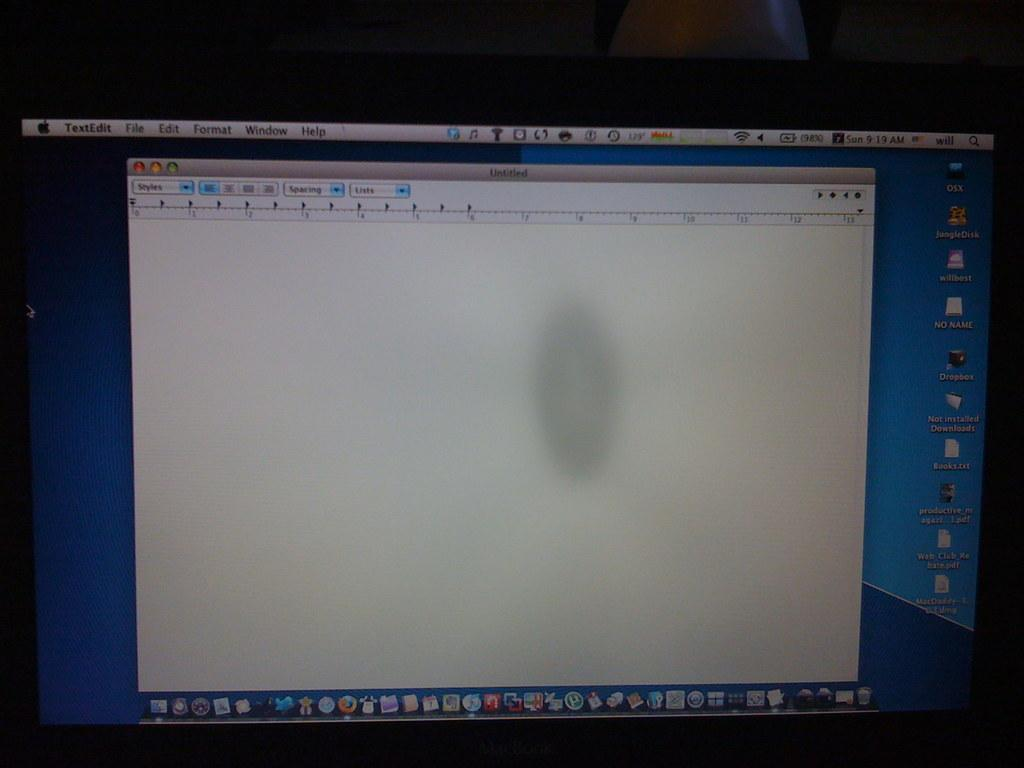<image>
Summarize the visual content of the image. A blank TextEdit page is open at 9:19 am. 